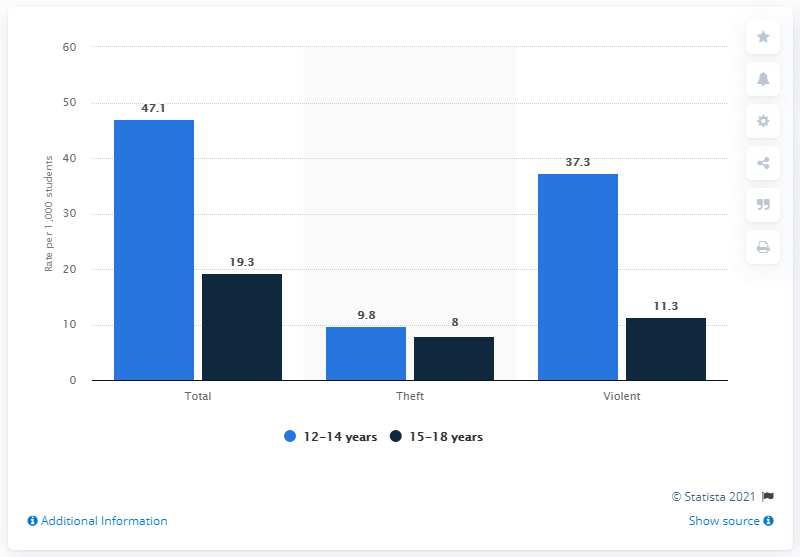Specify some key components in this picture. Out of the 3 bars, only 1 has a value below 12. The color of the leftmost bar is blue. In 2018, approximately 9.8% of students between the ages of 12 and 14 were victims of theft. 